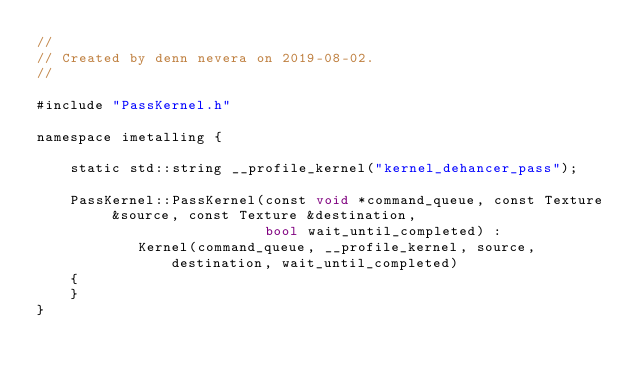Convert code to text. <code><loc_0><loc_0><loc_500><loc_500><_ObjectiveC_>//
// Created by denn nevera on 2019-08-02.
//

#include "PassKernel.h"

namespace imetalling {

    static std::string __profile_kernel("kernel_dehancer_pass");

    PassKernel::PassKernel(const void *command_queue, const Texture &source, const Texture &destination,
                           bool wait_until_completed) :
            Kernel(command_queue, __profile_kernel, source, destination, wait_until_completed)
    {
    }
}</code> 